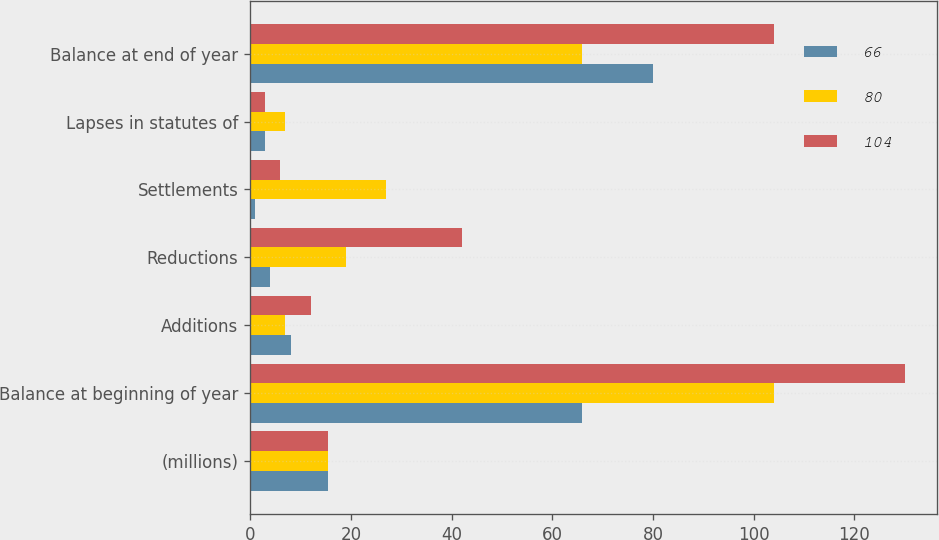<chart> <loc_0><loc_0><loc_500><loc_500><stacked_bar_chart><ecel><fcel>(millions)<fcel>Balance at beginning of year<fcel>Additions<fcel>Reductions<fcel>Settlements<fcel>Lapses in statutes of<fcel>Balance at end of year<nl><fcel>66<fcel>15.5<fcel>66<fcel>8<fcel>4<fcel>1<fcel>3<fcel>80<nl><fcel>80<fcel>15.5<fcel>104<fcel>7<fcel>19<fcel>27<fcel>7<fcel>66<nl><fcel>104<fcel>15.5<fcel>130<fcel>12<fcel>42<fcel>6<fcel>3<fcel>104<nl></chart> 